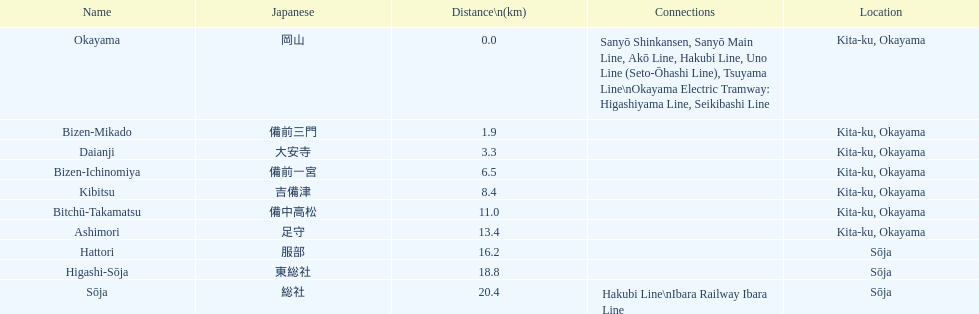How many consecutive stops must you travel through is you board the kibi line at bizen-mikado at depart at kibitsu? 2. 